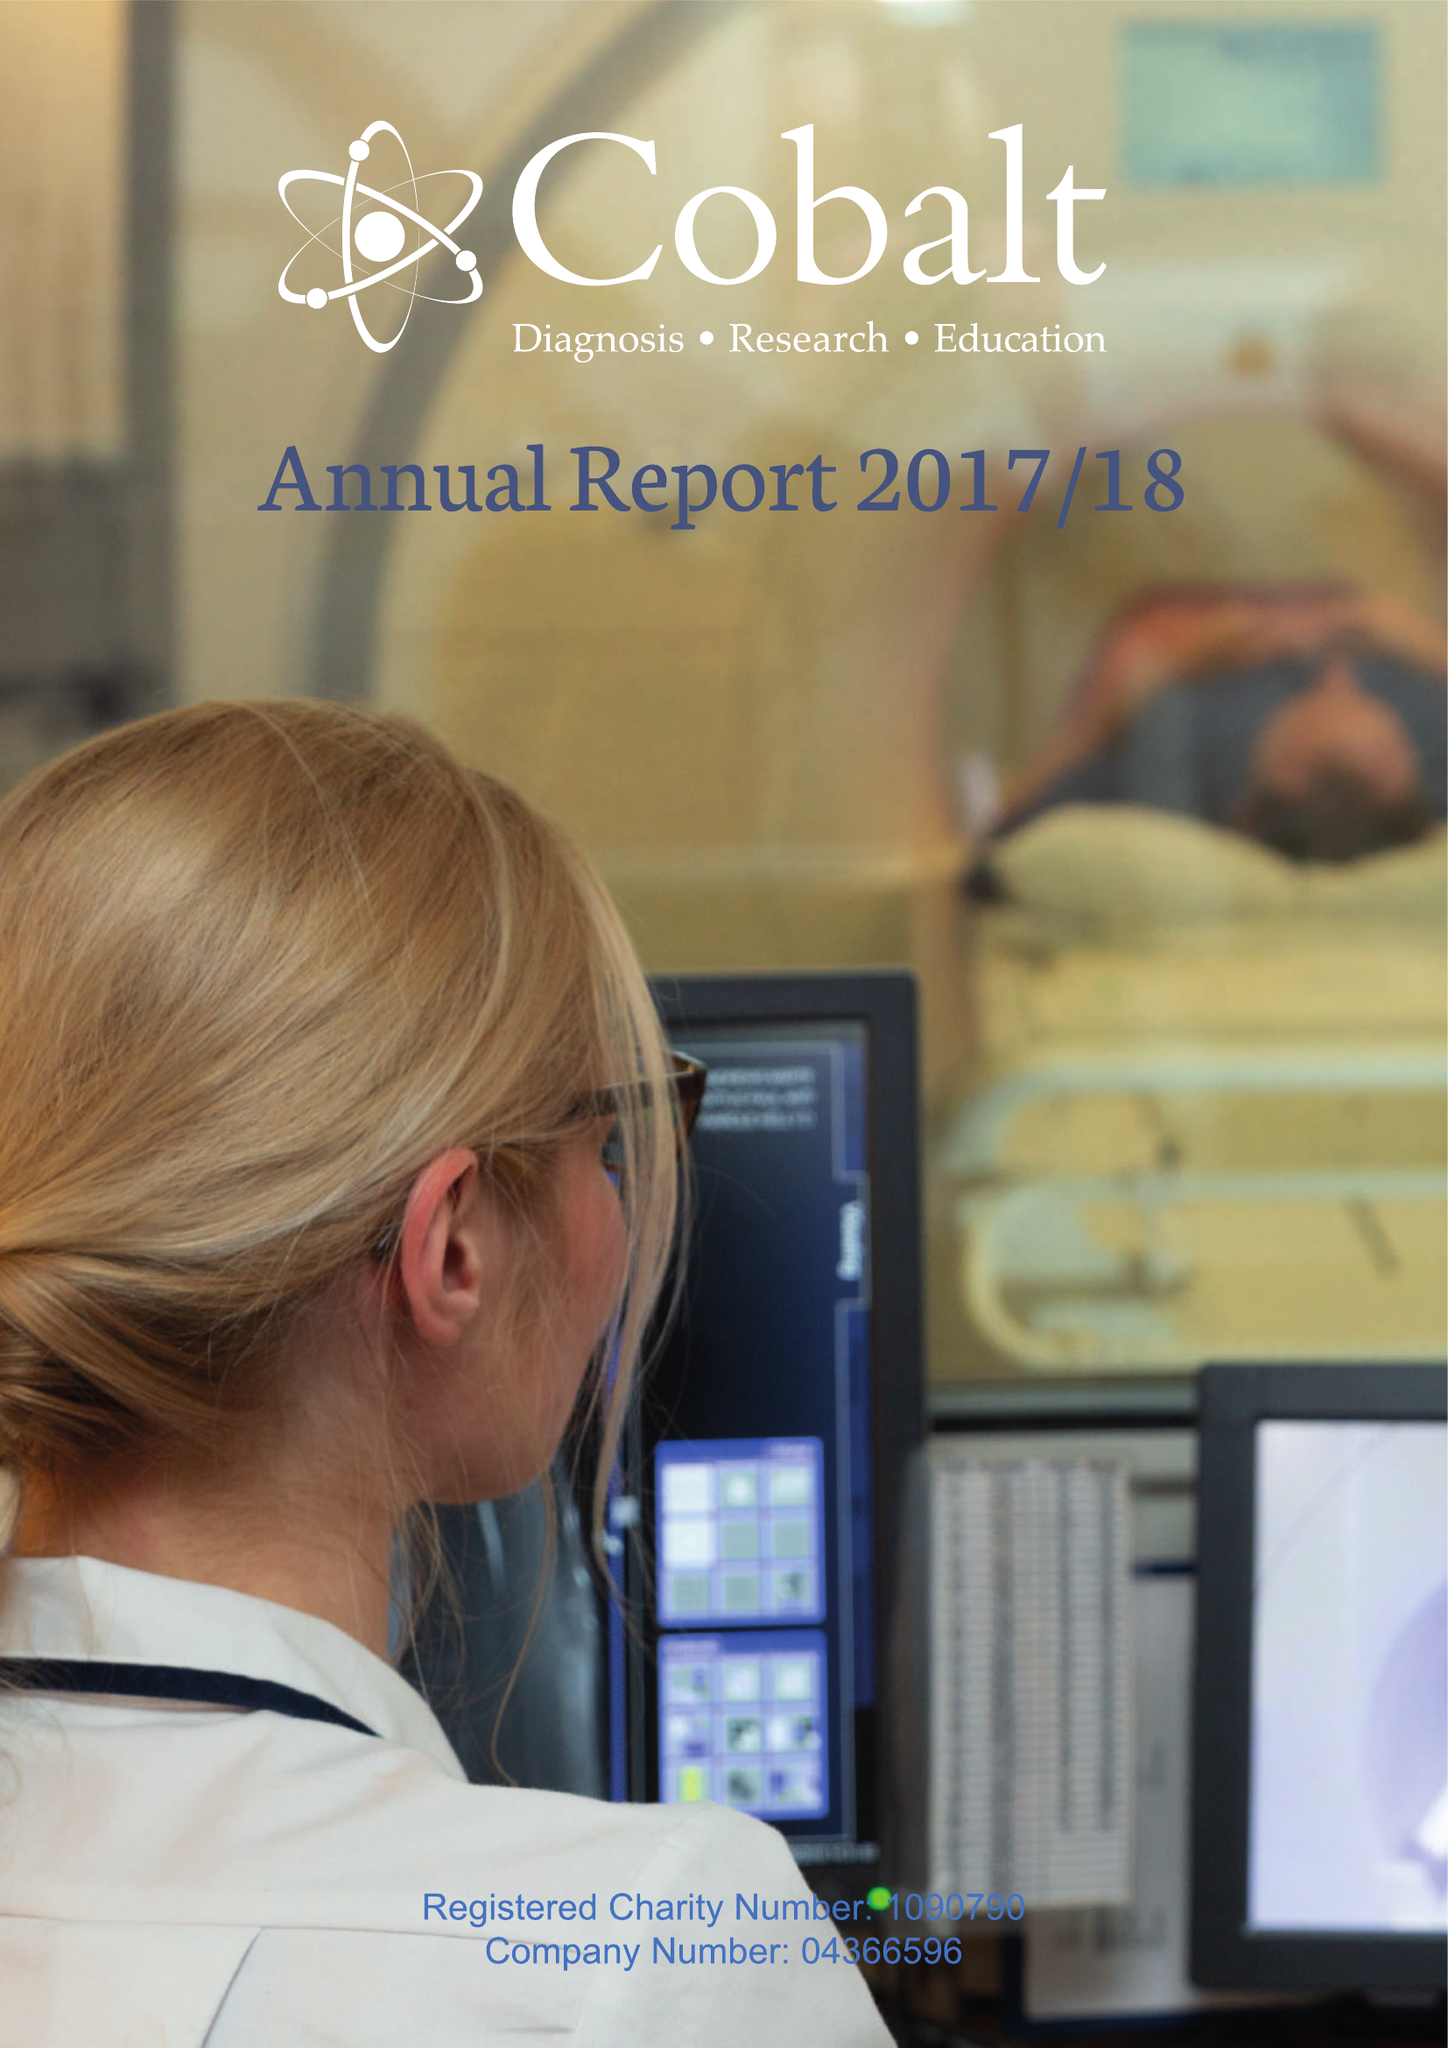What is the value for the income_annually_in_british_pounds?
Answer the question using a single word or phrase. 10604714.00 